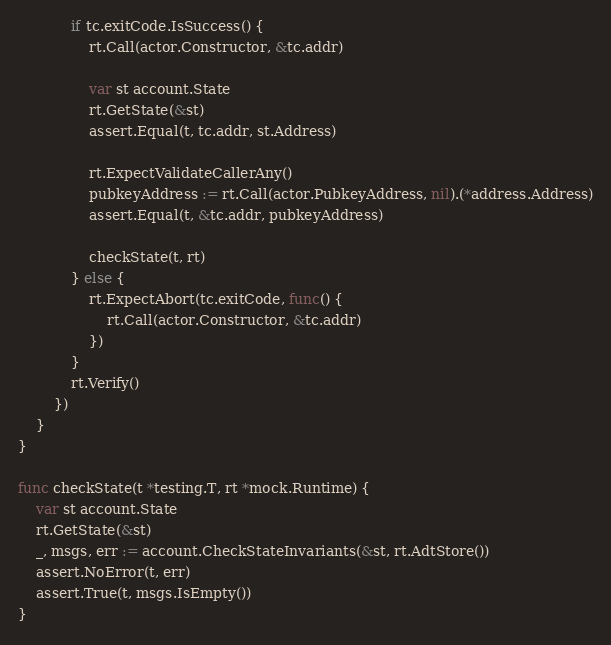Convert code to text. <code><loc_0><loc_0><loc_500><loc_500><_Go_>
			if tc.exitCode.IsSuccess() {
				rt.Call(actor.Constructor, &tc.addr)

				var st account.State
				rt.GetState(&st)
				assert.Equal(t, tc.addr, st.Address)

				rt.ExpectValidateCallerAny()
				pubkeyAddress := rt.Call(actor.PubkeyAddress, nil).(*address.Address)
				assert.Equal(t, &tc.addr, pubkeyAddress)

				checkState(t, rt)
			} else {
				rt.ExpectAbort(tc.exitCode, func() {
					rt.Call(actor.Constructor, &tc.addr)
				})
			}
			rt.Verify()
		})
	}
}

func checkState(t *testing.T, rt *mock.Runtime) {
	var st account.State
	rt.GetState(&st)
	_, msgs, err := account.CheckStateInvariants(&st, rt.AdtStore())
	assert.NoError(t, err)
	assert.True(t, msgs.IsEmpty())
}
</code> 